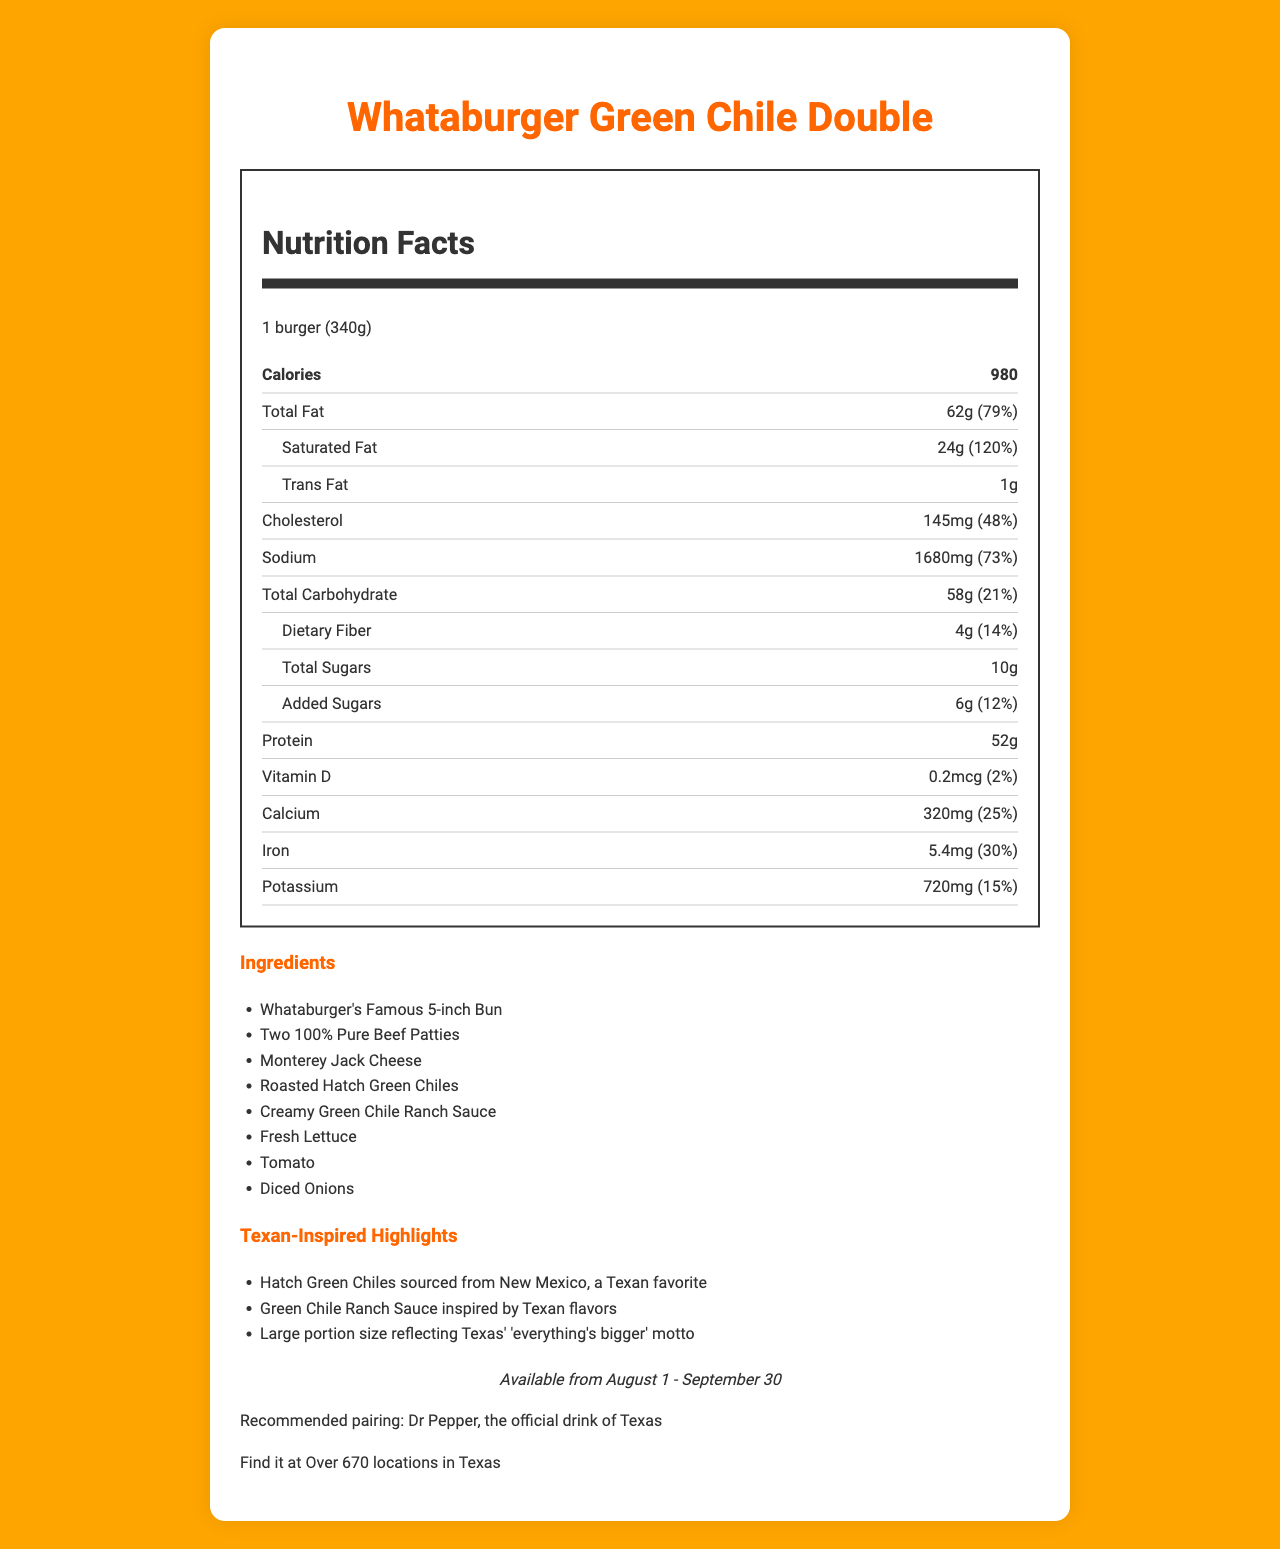what is the serving size of the Whataburger Green Chile Double? The document explicitly lists the serving size as "1 burger (340g)".
Answer: 1 burger (340g) how many calories are in one serving of the Green Chile Double? According to the document, one serving of the Green Chile Double contains 980 calories.
Answer: 980 calories what are the main ingredients in the Green Chile Double? The ingredients are listed under the section "Ingredients" in the document.
Answer: Whataburger's Famous 5-inch Bun, Two 100% Pure Beef Patties, Monterey Jack Cheese, Roasted Hatch Green Chiles, Creamy Green Chile Ranch Sauce, Fresh Lettuce, Tomato, Diced Onions how many grams of total fat are in one serving? The total fat amount per serving is provided in the document as 62g.
Answer: 62g what percentage of the daily value of saturated fat does one serving provide? The document states that one serving provides 120% of the daily value for saturated fat.
Answer: 120% which allergens are present in the Green Chile Double? The document lists "Wheat," "Milk," and "Soy" as allergens present in the Green Chile Double.
Answer: Wheat, Milk, Soy which vitamin listed has the lowest percentage daily value? A. Vitamin D B. Calcium C. Iron D. Potassium The document shows that Vitamin D has a 2% daily value, which is the lowest among the listed vitamins and minerals.
Answer: A. Vitamin D how much sodium does one serving contain? A. 145mg B. 320mg C. 720mg D. 1680mg The document states that one serving contains 1680mg of sodium.
Answer: D. 1680mg is the Green Chile Double available year-round? The document specifies an availability period from August 1 to September 30, indicating it is not available year-round.
Answer: No does this burger contain any trans fat? The document states that the Green Chile Double contains 1g of trans fat.
Answer: Yes what is the main theme of the document? The document focuses on the nutritional facts, ingredients, Texan-inspired elements, and availability information for the Green Chile Double.
Answer: The document provides nutritional information, ingredients, and Texan-inspired highlights for Whataburger's limited-time Green Chile Double. how much dietary fiber is in the burger? The document clearly specifies that the dietary fiber content is 4g per serving.
Answer: 4g what drink pairs well with the Green Chile Double according to the document? The document recommends pairing the Green Chile Double with Dr Pepper, the official drink of Texas.
Answer: Dr Pepper which ingredient gives the burger its Texan flavor? The document highlights that the Roasted Hatch Green Chiles are inspired by Texan flavors.
Answer: Roasted Hatch Green Chiles what is the largest source of protein in the burger? The beef patties are likely the largest source of protein, given they are a primary ingredient and the burger contains a high protein content of 52g.
Answer: Two 100% Pure Beef Patties does the serving size contain more than 1000mg of sodium? True or False The document specifies that one serving contains 1680mg of sodium, which is more than 1000mg.
Answer: True can we determine the price of the Green Chile Double from the document? The document does not provide any information about the price of the Green Chile Double.
Answer: Not enough information 